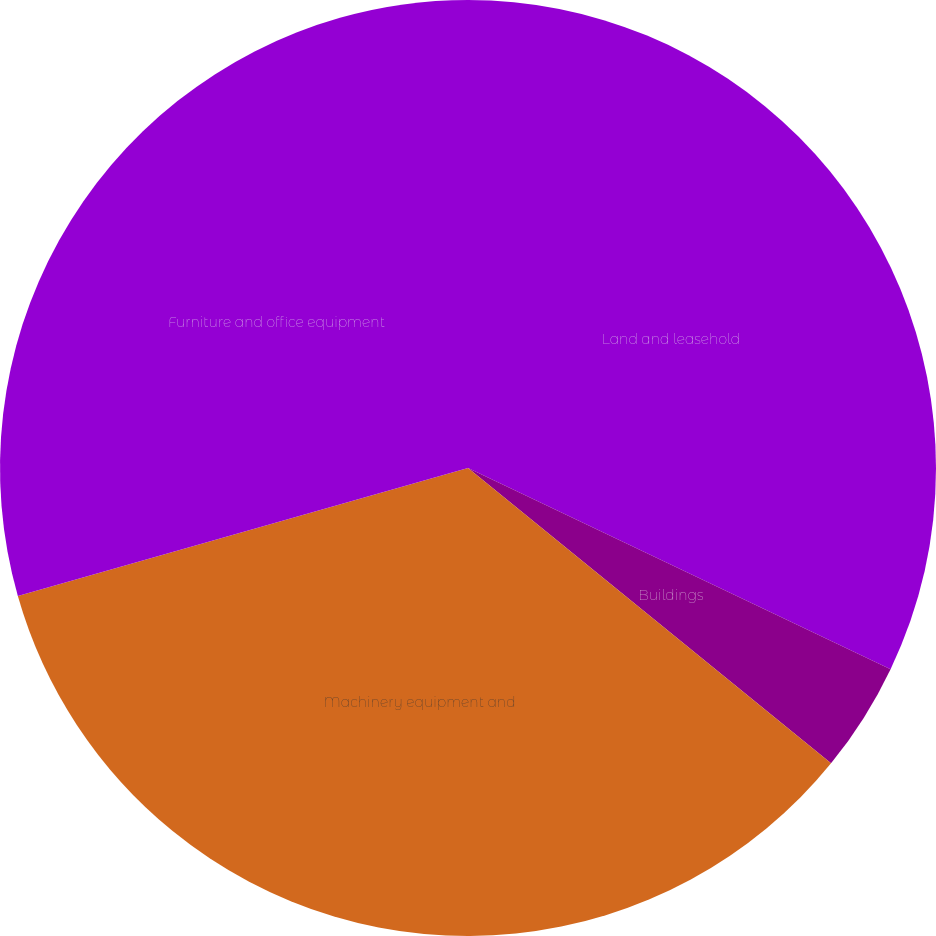Convert chart. <chart><loc_0><loc_0><loc_500><loc_500><pie_chart><fcel>Land and leasehold<fcel>Buildings<fcel>Machinery equipment and<fcel>Furniture and office equipment<nl><fcel>32.07%<fcel>3.8%<fcel>34.72%<fcel>29.41%<nl></chart> 